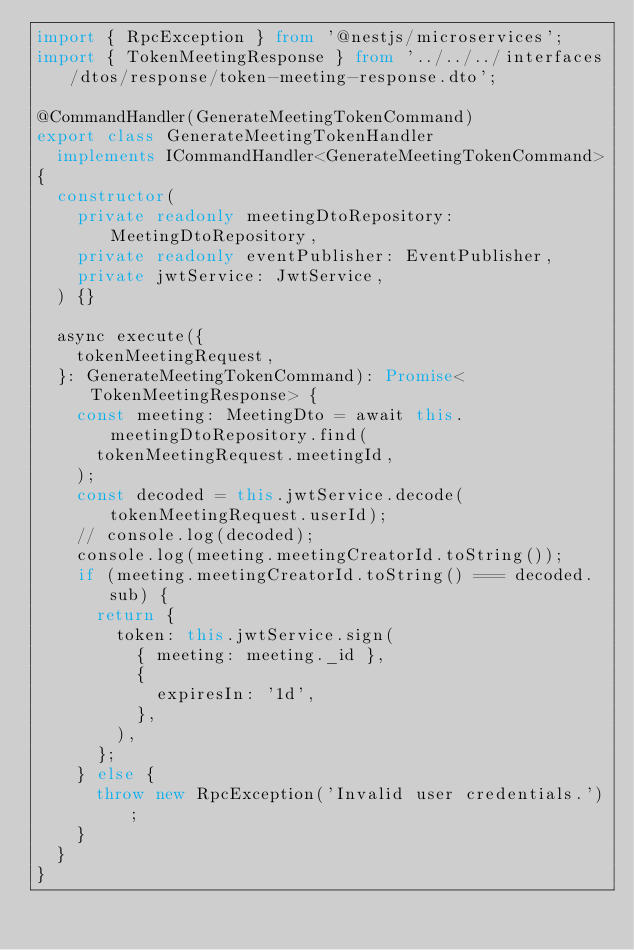Convert code to text. <code><loc_0><loc_0><loc_500><loc_500><_TypeScript_>import { RpcException } from '@nestjs/microservices';
import { TokenMeetingResponse } from '../../../interfaces/dtos/response/token-meeting-response.dto';

@CommandHandler(GenerateMeetingTokenCommand)
export class GenerateMeetingTokenHandler
  implements ICommandHandler<GenerateMeetingTokenCommand>
{
  constructor(
    private readonly meetingDtoRepository: MeetingDtoRepository,
    private readonly eventPublisher: EventPublisher,
    private jwtService: JwtService,
  ) {}

  async execute({
    tokenMeetingRequest,
  }: GenerateMeetingTokenCommand): Promise<TokenMeetingResponse> {
    const meeting: MeetingDto = await this.meetingDtoRepository.find(
      tokenMeetingRequest.meetingId,
    );
    const decoded = this.jwtService.decode(tokenMeetingRequest.userId);
    // console.log(decoded);
    console.log(meeting.meetingCreatorId.toString());
    if (meeting.meetingCreatorId.toString() === decoded.sub) {
      return {
        token: this.jwtService.sign(
          { meeting: meeting._id },
          {
            expiresIn: '1d',
          },
        ),
      };
    } else {
      throw new RpcException('Invalid user credentials.');
    }
  }
}
</code> 